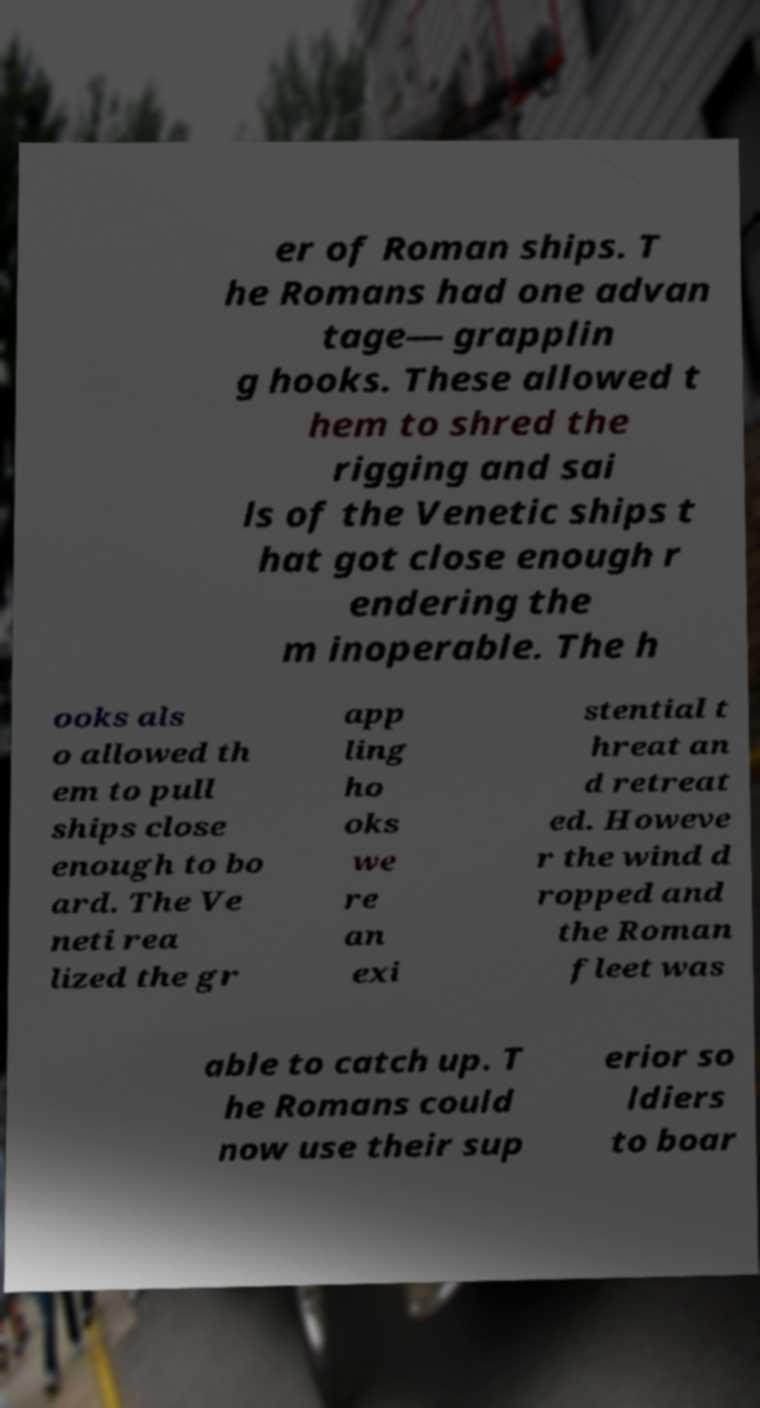Could you assist in decoding the text presented in this image and type it out clearly? er of Roman ships. T he Romans had one advan tage— grapplin g hooks. These allowed t hem to shred the rigging and sai ls of the Venetic ships t hat got close enough r endering the m inoperable. The h ooks als o allowed th em to pull ships close enough to bo ard. The Ve neti rea lized the gr app ling ho oks we re an exi stential t hreat an d retreat ed. Howeve r the wind d ropped and the Roman fleet was able to catch up. T he Romans could now use their sup erior so ldiers to boar 